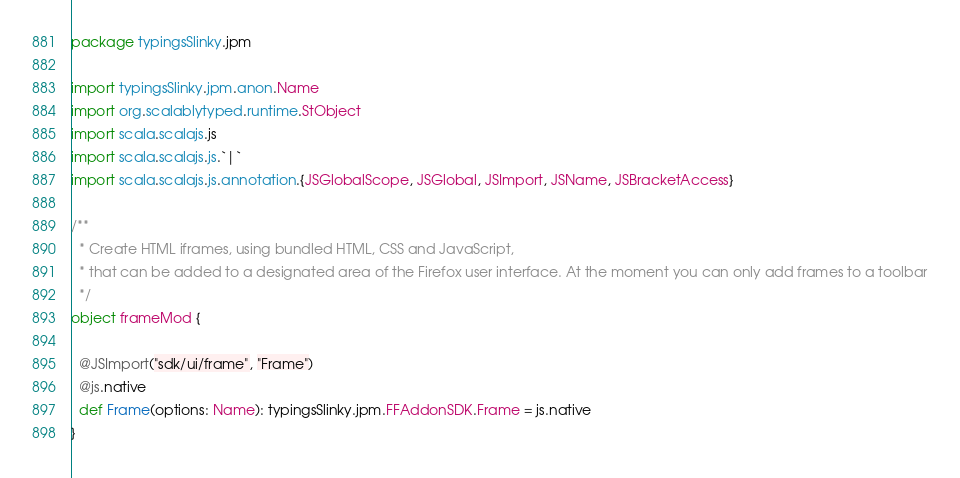Convert code to text. <code><loc_0><loc_0><loc_500><loc_500><_Scala_>package typingsSlinky.jpm

import typingsSlinky.jpm.anon.Name
import org.scalablytyped.runtime.StObject
import scala.scalajs.js
import scala.scalajs.js.`|`
import scala.scalajs.js.annotation.{JSGlobalScope, JSGlobal, JSImport, JSName, JSBracketAccess}

/**
  * Create HTML iframes, using bundled HTML, CSS and JavaScript,
  * that can be added to a designated area of the Firefox user interface. At the moment you can only add frames to a toolbar
  */
object frameMod {
  
  @JSImport("sdk/ui/frame", "Frame")
  @js.native
  def Frame(options: Name): typingsSlinky.jpm.FFAddonSDK.Frame = js.native
}
</code> 